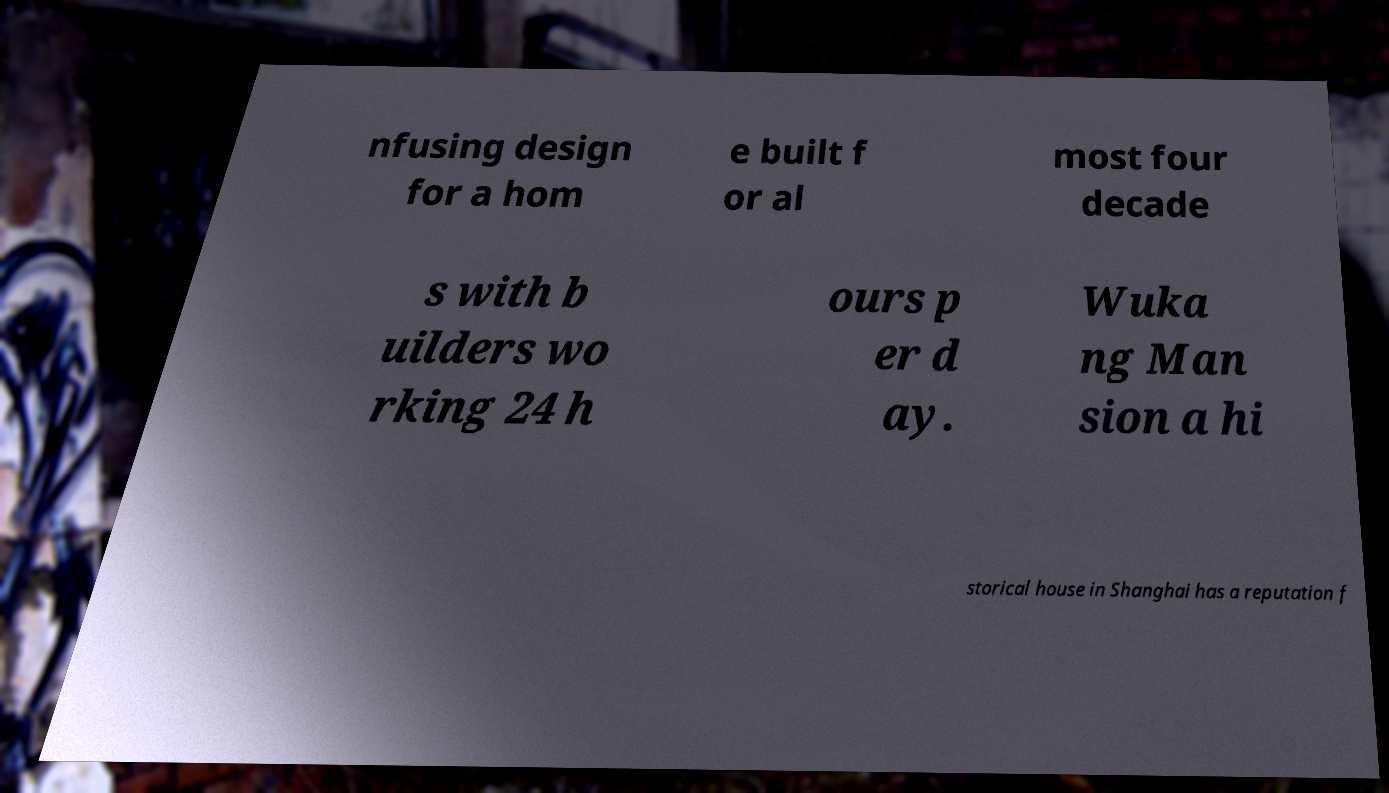Please read and relay the text visible in this image. What does it say? nfusing design for a hom e built f or al most four decade s with b uilders wo rking 24 h ours p er d ay. Wuka ng Man sion a hi storical house in Shanghai has a reputation f 